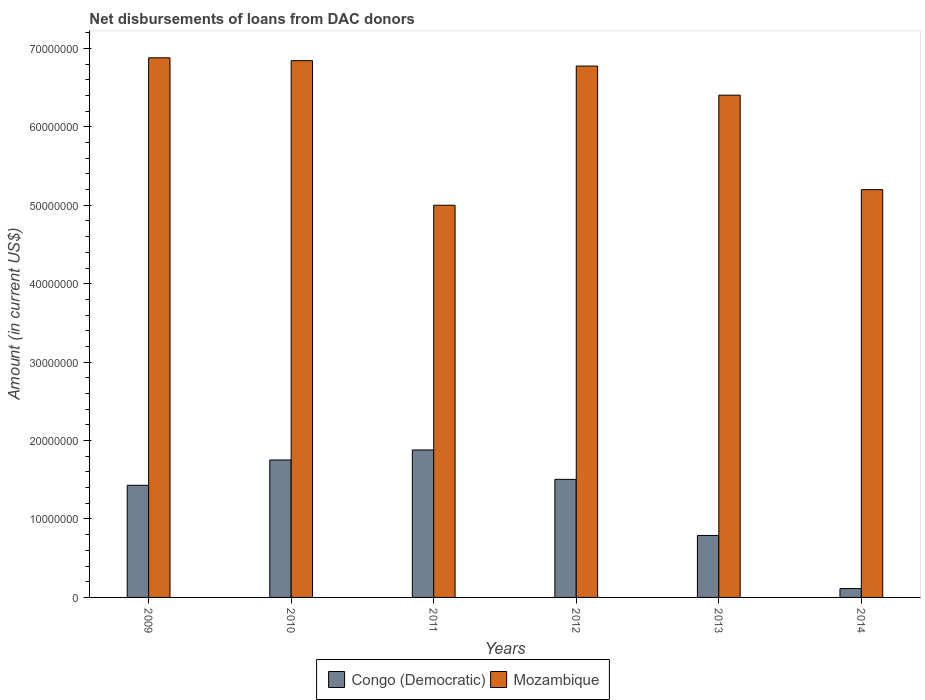How many groups of bars are there?
Ensure brevity in your answer.  6. Are the number of bars per tick equal to the number of legend labels?
Your answer should be very brief. Yes. Are the number of bars on each tick of the X-axis equal?
Offer a very short reply. Yes. How many bars are there on the 2nd tick from the left?
Provide a succinct answer. 2. How many bars are there on the 5th tick from the right?
Ensure brevity in your answer.  2. What is the amount of loans disbursed in Congo (Democratic) in 2010?
Make the answer very short. 1.75e+07. Across all years, what is the maximum amount of loans disbursed in Mozambique?
Provide a short and direct response. 6.88e+07. Across all years, what is the minimum amount of loans disbursed in Mozambique?
Make the answer very short. 5.00e+07. In which year was the amount of loans disbursed in Congo (Democratic) minimum?
Your response must be concise. 2014. What is the total amount of loans disbursed in Mozambique in the graph?
Give a very brief answer. 3.71e+08. What is the difference between the amount of loans disbursed in Congo (Democratic) in 2009 and that in 2010?
Keep it short and to the point. -3.23e+06. What is the difference between the amount of loans disbursed in Mozambique in 2009 and the amount of loans disbursed in Congo (Democratic) in 2012?
Give a very brief answer. 5.38e+07. What is the average amount of loans disbursed in Mozambique per year?
Your answer should be very brief. 6.18e+07. In the year 2012, what is the difference between the amount of loans disbursed in Congo (Democratic) and amount of loans disbursed in Mozambique?
Offer a terse response. -5.27e+07. In how many years, is the amount of loans disbursed in Congo (Democratic) greater than 10000000 US$?
Give a very brief answer. 4. What is the ratio of the amount of loans disbursed in Congo (Democratic) in 2009 to that in 2014?
Offer a very short reply. 12.65. Is the amount of loans disbursed in Congo (Democratic) in 2011 less than that in 2013?
Your response must be concise. No. Is the difference between the amount of loans disbursed in Congo (Democratic) in 2011 and 2012 greater than the difference between the amount of loans disbursed in Mozambique in 2011 and 2012?
Ensure brevity in your answer.  Yes. What is the difference between the highest and the second highest amount of loans disbursed in Congo (Democratic)?
Your answer should be very brief. 1.28e+06. What is the difference between the highest and the lowest amount of loans disbursed in Congo (Democratic)?
Your answer should be compact. 1.77e+07. Is the sum of the amount of loans disbursed in Mozambique in 2011 and 2012 greater than the maximum amount of loans disbursed in Congo (Democratic) across all years?
Your response must be concise. Yes. What does the 2nd bar from the left in 2009 represents?
Provide a succinct answer. Mozambique. What does the 2nd bar from the right in 2010 represents?
Ensure brevity in your answer.  Congo (Democratic). Are all the bars in the graph horizontal?
Offer a very short reply. No. What is the difference between two consecutive major ticks on the Y-axis?
Make the answer very short. 1.00e+07. Are the values on the major ticks of Y-axis written in scientific E-notation?
Offer a very short reply. No. Does the graph contain grids?
Your answer should be very brief. No. How are the legend labels stacked?
Give a very brief answer. Horizontal. What is the title of the graph?
Keep it short and to the point. Net disbursements of loans from DAC donors. Does "El Salvador" appear as one of the legend labels in the graph?
Your answer should be compact. No. What is the label or title of the X-axis?
Offer a very short reply. Years. What is the label or title of the Y-axis?
Provide a short and direct response. Amount (in current US$). What is the Amount (in current US$) of Congo (Democratic) in 2009?
Keep it short and to the point. 1.43e+07. What is the Amount (in current US$) of Mozambique in 2009?
Give a very brief answer. 6.88e+07. What is the Amount (in current US$) in Congo (Democratic) in 2010?
Provide a short and direct response. 1.75e+07. What is the Amount (in current US$) in Mozambique in 2010?
Provide a short and direct response. 6.84e+07. What is the Amount (in current US$) of Congo (Democratic) in 2011?
Offer a terse response. 1.88e+07. What is the Amount (in current US$) in Mozambique in 2011?
Your response must be concise. 5.00e+07. What is the Amount (in current US$) in Congo (Democratic) in 2012?
Your response must be concise. 1.51e+07. What is the Amount (in current US$) of Mozambique in 2012?
Your response must be concise. 6.78e+07. What is the Amount (in current US$) of Congo (Democratic) in 2013?
Ensure brevity in your answer.  7.90e+06. What is the Amount (in current US$) of Mozambique in 2013?
Ensure brevity in your answer.  6.40e+07. What is the Amount (in current US$) in Congo (Democratic) in 2014?
Make the answer very short. 1.13e+06. What is the Amount (in current US$) in Mozambique in 2014?
Offer a very short reply. 5.20e+07. Across all years, what is the maximum Amount (in current US$) in Congo (Democratic)?
Offer a very short reply. 1.88e+07. Across all years, what is the maximum Amount (in current US$) of Mozambique?
Give a very brief answer. 6.88e+07. Across all years, what is the minimum Amount (in current US$) in Congo (Democratic)?
Provide a succinct answer. 1.13e+06. Across all years, what is the minimum Amount (in current US$) of Mozambique?
Give a very brief answer. 5.00e+07. What is the total Amount (in current US$) in Congo (Democratic) in the graph?
Give a very brief answer. 7.47e+07. What is the total Amount (in current US$) of Mozambique in the graph?
Ensure brevity in your answer.  3.71e+08. What is the difference between the Amount (in current US$) in Congo (Democratic) in 2009 and that in 2010?
Offer a very short reply. -3.23e+06. What is the difference between the Amount (in current US$) in Mozambique in 2009 and that in 2010?
Your answer should be compact. 3.64e+05. What is the difference between the Amount (in current US$) of Congo (Democratic) in 2009 and that in 2011?
Ensure brevity in your answer.  -4.50e+06. What is the difference between the Amount (in current US$) of Mozambique in 2009 and that in 2011?
Give a very brief answer. 1.88e+07. What is the difference between the Amount (in current US$) of Congo (Democratic) in 2009 and that in 2012?
Make the answer very short. -7.55e+05. What is the difference between the Amount (in current US$) of Mozambique in 2009 and that in 2012?
Make the answer very short. 1.05e+06. What is the difference between the Amount (in current US$) of Congo (Democratic) in 2009 and that in 2013?
Provide a succinct answer. 6.40e+06. What is the difference between the Amount (in current US$) in Mozambique in 2009 and that in 2013?
Make the answer very short. 4.76e+06. What is the difference between the Amount (in current US$) of Congo (Democratic) in 2009 and that in 2014?
Offer a terse response. 1.32e+07. What is the difference between the Amount (in current US$) of Mozambique in 2009 and that in 2014?
Keep it short and to the point. 1.68e+07. What is the difference between the Amount (in current US$) of Congo (Democratic) in 2010 and that in 2011?
Your response must be concise. -1.28e+06. What is the difference between the Amount (in current US$) of Mozambique in 2010 and that in 2011?
Give a very brief answer. 1.84e+07. What is the difference between the Amount (in current US$) in Congo (Democratic) in 2010 and that in 2012?
Give a very brief answer. 2.47e+06. What is the difference between the Amount (in current US$) in Mozambique in 2010 and that in 2012?
Ensure brevity in your answer.  6.87e+05. What is the difference between the Amount (in current US$) of Congo (Democratic) in 2010 and that in 2013?
Offer a very short reply. 9.62e+06. What is the difference between the Amount (in current US$) in Mozambique in 2010 and that in 2013?
Give a very brief answer. 4.40e+06. What is the difference between the Amount (in current US$) in Congo (Democratic) in 2010 and that in 2014?
Provide a short and direct response. 1.64e+07. What is the difference between the Amount (in current US$) in Mozambique in 2010 and that in 2014?
Keep it short and to the point. 1.64e+07. What is the difference between the Amount (in current US$) in Congo (Democratic) in 2011 and that in 2012?
Make the answer very short. 3.75e+06. What is the difference between the Amount (in current US$) of Mozambique in 2011 and that in 2012?
Make the answer very short. -1.78e+07. What is the difference between the Amount (in current US$) in Congo (Democratic) in 2011 and that in 2013?
Provide a succinct answer. 1.09e+07. What is the difference between the Amount (in current US$) of Mozambique in 2011 and that in 2013?
Make the answer very short. -1.40e+07. What is the difference between the Amount (in current US$) in Congo (Democratic) in 2011 and that in 2014?
Your answer should be very brief. 1.77e+07. What is the difference between the Amount (in current US$) of Mozambique in 2011 and that in 2014?
Your answer should be very brief. -1.99e+06. What is the difference between the Amount (in current US$) of Congo (Democratic) in 2012 and that in 2013?
Offer a terse response. 7.15e+06. What is the difference between the Amount (in current US$) in Mozambique in 2012 and that in 2013?
Your response must be concise. 3.71e+06. What is the difference between the Amount (in current US$) in Congo (Democratic) in 2012 and that in 2014?
Your response must be concise. 1.39e+07. What is the difference between the Amount (in current US$) in Mozambique in 2012 and that in 2014?
Provide a short and direct response. 1.58e+07. What is the difference between the Amount (in current US$) in Congo (Democratic) in 2013 and that in 2014?
Your answer should be very brief. 6.77e+06. What is the difference between the Amount (in current US$) in Mozambique in 2013 and that in 2014?
Your answer should be very brief. 1.20e+07. What is the difference between the Amount (in current US$) in Congo (Democratic) in 2009 and the Amount (in current US$) in Mozambique in 2010?
Provide a short and direct response. -5.41e+07. What is the difference between the Amount (in current US$) in Congo (Democratic) in 2009 and the Amount (in current US$) in Mozambique in 2011?
Give a very brief answer. -3.57e+07. What is the difference between the Amount (in current US$) of Congo (Democratic) in 2009 and the Amount (in current US$) of Mozambique in 2012?
Make the answer very short. -5.35e+07. What is the difference between the Amount (in current US$) in Congo (Democratic) in 2009 and the Amount (in current US$) in Mozambique in 2013?
Provide a short and direct response. -4.97e+07. What is the difference between the Amount (in current US$) in Congo (Democratic) in 2009 and the Amount (in current US$) in Mozambique in 2014?
Your answer should be compact. -3.77e+07. What is the difference between the Amount (in current US$) in Congo (Democratic) in 2010 and the Amount (in current US$) in Mozambique in 2011?
Give a very brief answer. -3.25e+07. What is the difference between the Amount (in current US$) of Congo (Democratic) in 2010 and the Amount (in current US$) of Mozambique in 2012?
Ensure brevity in your answer.  -5.02e+07. What is the difference between the Amount (in current US$) of Congo (Democratic) in 2010 and the Amount (in current US$) of Mozambique in 2013?
Keep it short and to the point. -4.65e+07. What is the difference between the Amount (in current US$) in Congo (Democratic) in 2010 and the Amount (in current US$) in Mozambique in 2014?
Ensure brevity in your answer.  -3.45e+07. What is the difference between the Amount (in current US$) in Congo (Democratic) in 2011 and the Amount (in current US$) in Mozambique in 2012?
Provide a succinct answer. -4.90e+07. What is the difference between the Amount (in current US$) of Congo (Democratic) in 2011 and the Amount (in current US$) of Mozambique in 2013?
Provide a succinct answer. -4.52e+07. What is the difference between the Amount (in current US$) of Congo (Democratic) in 2011 and the Amount (in current US$) of Mozambique in 2014?
Provide a succinct answer. -3.32e+07. What is the difference between the Amount (in current US$) of Congo (Democratic) in 2012 and the Amount (in current US$) of Mozambique in 2013?
Your answer should be very brief. -4.90e+07. What is the difference between the Amount (in current US$) of Congo (Democratic) in 2012 and the Amount (in current US$) of Mozambique in 2014?
Ensure brevity in your answer.  -3.69e+07. What is the difference between the Amount (in current US$) of Congo (Democratic) in 2013 and the Amount (in current US$) of Mozambique in 2014?
Offer a terse response. -4.41e+07. What is the average Amount (in current US$) in Congo (Democratic) per year?
Your answer should be compact. 1.25e+07. What is the average Amount (in current US$) of Mozambique per year?
Ensure brevity in your answer.  6.18e+07. In the year 2009, what is the difference between the Amount (in current US$) of Congo (Democratic) and Amount (in current US$) of Mozambique?
Your answer should be compact. -5.45e+07. In the year 2010, what is the difference between the Amount (in current US$) in Congo (Democratic) and Amount (in current US$) in Mozambique?
Your answer should be very brief. -5.09e+07. In the year 2011, what is the difference between the Amount (in current US$) in Congo (Democratic) and Amount (in current US$) in Mozambique?
Offer a terse response. -3.12e+07. In the year 2012, what is the difference between the Amount (in current US$) of Congo (Democratic) and Amount (in current US$) of Mozambique?
Make the answer very short. -5.27e+07. In the year 2013, what is the difference between the Amount (in current US$) in Congo (Democratic) and Amount (in current US$) in Mozambique?
Keep it short and to the point. -5.61e+07. In the year 2014, what is the difference between the Amount (in current US$) of Congo (Democratic) and Amount (in current US$) of Mozambique?
Offer a very short reply. -5.09e+07. What is the ratio of the Amount (in current US$) in Congo (Democratic) in 2009 to that in 2010?
Provide a short and direct response. 0.82. What is the ratio of the Amount (in current US$) of Mozambique in 2009 to that in 2010?
Your response must be concise. 1.01. What is the ratio of the Amount (in current US$) of Congo (Democratic) in 2009 to that in 2011?
Your response must be concise. 0.76. What is the ratio of the Amount (in current US$) of Mozambique in 2009 to that in 2011?
Make the answer very short. 1.38. What is the ratio of the Amount (in current US$) of Congo (Democratic) in 2009 to that in 2012?
Ensure brevity in your answer.  0.95. What is the ratio of the Amount (in current US$) of Mozambique in 2009 to that in 2012?
Keep it short and to the point. 1.02. What is the ratio of the Amount (in current US$) of Congo (Democratic) in 2009 to that in 2013?
Give a very brief answer. 1.81. What is the ratio of the Amount (in current US$) in Mozambique in 2009 to that in 2013?
Your answer should be compact. 1.07. What is the ratio of the Amount (in current US$) of Congo (Democratic) in 2009 to that in 2014?
Offer a very short reply. 12.65. What is the ratio of the Amount (in current US$) of Mozambique in 2009 to that in 2014?
Your response must be concise. 1.32. What is the ratio of the Amount (in current US$) in Congo (Democratic) in 2010 to that in 2011?
Your answer should be very brief. 0.93. What is the ratio of the Amount (in current US$) of Mozambique in 2010 to that in 2011?
Make the answer very short. 1.37. What is the ratio of the Amount (in current US$) in Congo (Democratic) in 2010 to that in 2012?
Make the answer very short. 1.16. What is the ratio of the Amount (in current US$) in Mozambique in 2010 to that in 2012?
Your answer should be very brief. 1.01. What is the ratio of the Amount (in current US$) in Congo (Democratic) in 2010 to that in 2013?
Give a very brief answer. 2.22. What is the ratio of the Amount (in current US$) in Mozambique in 2010 to that in 2013?
Your answer should be very brief. 1.07. What is the ratio of the Amount (in current US$) in Congo (Democratic) in 2010 to that in 2014?
Offer a terse response. 15.51. What is the ratio of the Amount (in current US$) in Mozambique in 2010 to that in 2014?
Your answer should be compact. 1.32. What is the ratio of the Amount (in current US$) of Congo (Democratic) in 2011 to that in 2012?
Your response must be concise. 1.25. What is the ratio of the Amount (in current US$) of Mozambique in 2011 to that in 2012?
Your answer should be very brief. 0.74. What is the ratio of the Amount (in current US$) in Congo (Democratic) in 2011 to that in 2013?
Provide a succinct answer. 2.38. What is the ratio of the Amount (in current US$) in Mozambique in 2011 to that in 2013?
Your answer should be compact. 0.78. What is the ratio of the Amount (in current US$) of Congo (Democratic) in 2011 to that in 2014?
Offer a terse response. 16.64. What is the ratio of the Amount (in current US$) in Mozambique in 2011 to that in 2014?
Your answer should be very brief. 0.96. What is the ratio of the Amount (in current US$) in Congo (Democratic) in 2012 to that in 2013?
Give a very brief answer. 1.9. What is the ratio of the Amount (in current US$) of Mozambique in 2012 to that in 2013?
Offer a terse response. 1.06. What is the ratio of the Amount (in current US$) in Congo (Democratic) in 2012 to that in 2014?
Provide a short and direct response. 13.32. What is the ratio of the Amount (in current US$) of Mozambique in 2012 to that in 2014?
Provide a short and direct response. 1.3. What is the ratio of the Amount (in current US$) in Congo (Democratic) in 2013 to that in 2014?
Give a very brief answer. 6.99. What is the ratio of the Amount (in current US$) of Mozambique in 2013 to that in 2014?
Offer a terse response. 1.23. What is the difference between the highest and the second highest Amount (in current US$) of Congo (Democratic)?
Your response must be concise. 1.28e+06. What is the difference between the highest and the second highest Amount (in current US$) in Mozambique?
Make the answer very short. 3.64e+05. What is the difference between the highest and the lowest Amount (in current US$) in Congo (Democratic)?
Offer a very short reply. 1.77e+07. What is the difference between the highest and the lowest Amount (in current US$) in Mozambique?
Your response must be concise. 1.88e+07. 